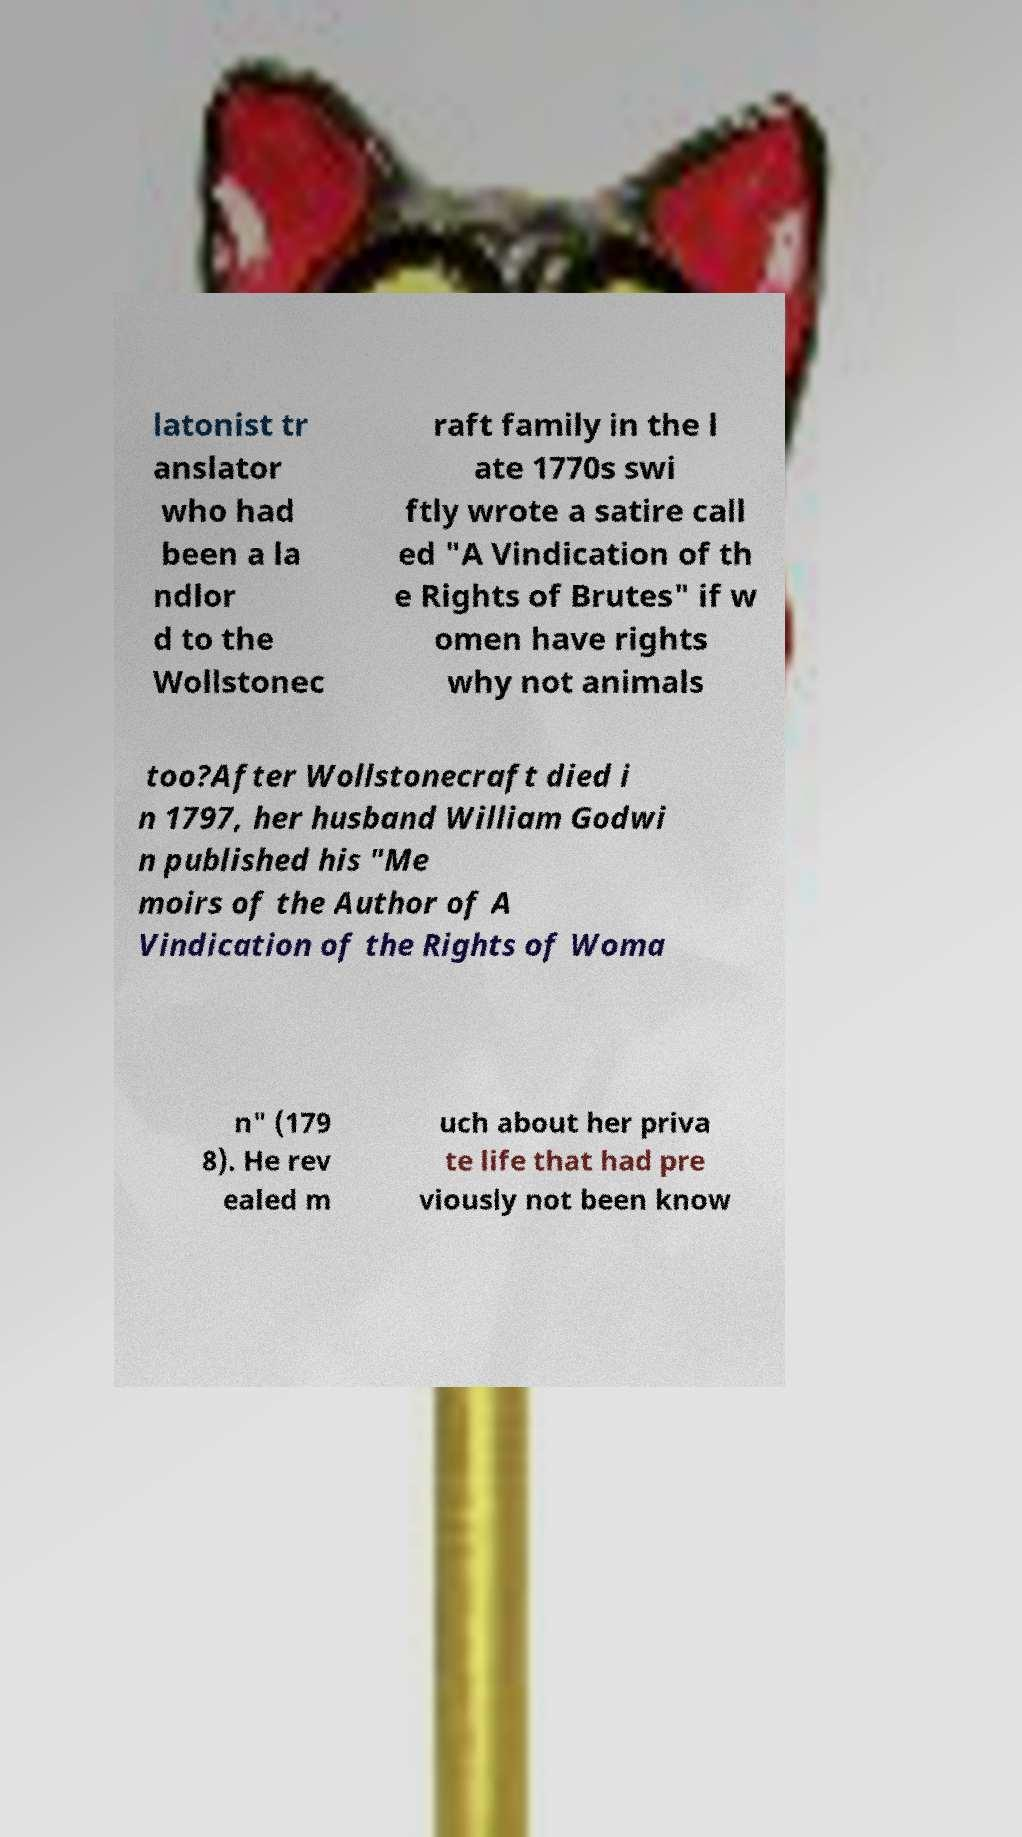Please identify and transcribe the text found in this image. latonist tr anslator who had been a la ndlor d to the Wollstonec raft family in the l ate 1770s swi ftly wrote a satire call ed "A Vindication of th e Rights of Brutes" if w omen have rights why not animals too?After Wollstonecraft died i n 1797, her husband William Godwi n published his "Me moirs of the Author of A Vindication of the Rights of Woma n" (179 8). He rev ealed m uch about her priva te life that had pre viously not been know 